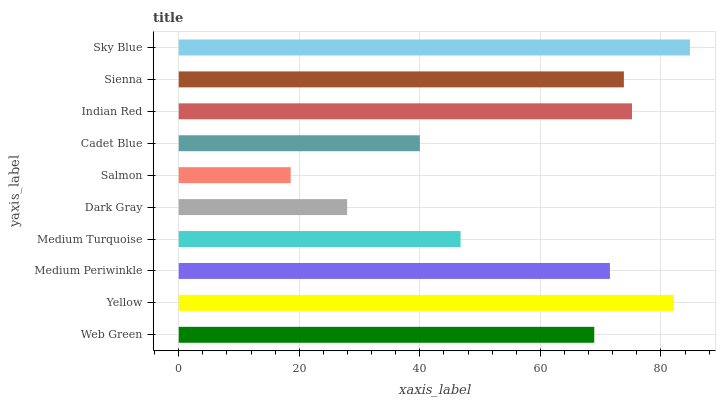Is Salmon the minimum?
Answer yes or no. Yes. Is Sky Blue the maximum?
Answer yes or no. Yes. Is Yellow the minimum?
Answer yes or no. No. Is Yellow the maximum?
Answer yes or no. No. Is Yellow greater than Web Green?
Answer yes or no. Yes. Is Web Green less than Yellow?
Answer yes or no. Yes. Is Web Green greater than Yellow?
Answer yes or no. No. Is Yellow less than Web Green?
Answer yes or no. No. Is Medium Periwinkle the high median?
Answer yes or no. Yes. Is Web Green the low median?
Answer yes or no. Yes. Is Indian Red the high median?
Answer yes or no. No. Is Medium Turquoise the low median?
Answer yes or no. No. 